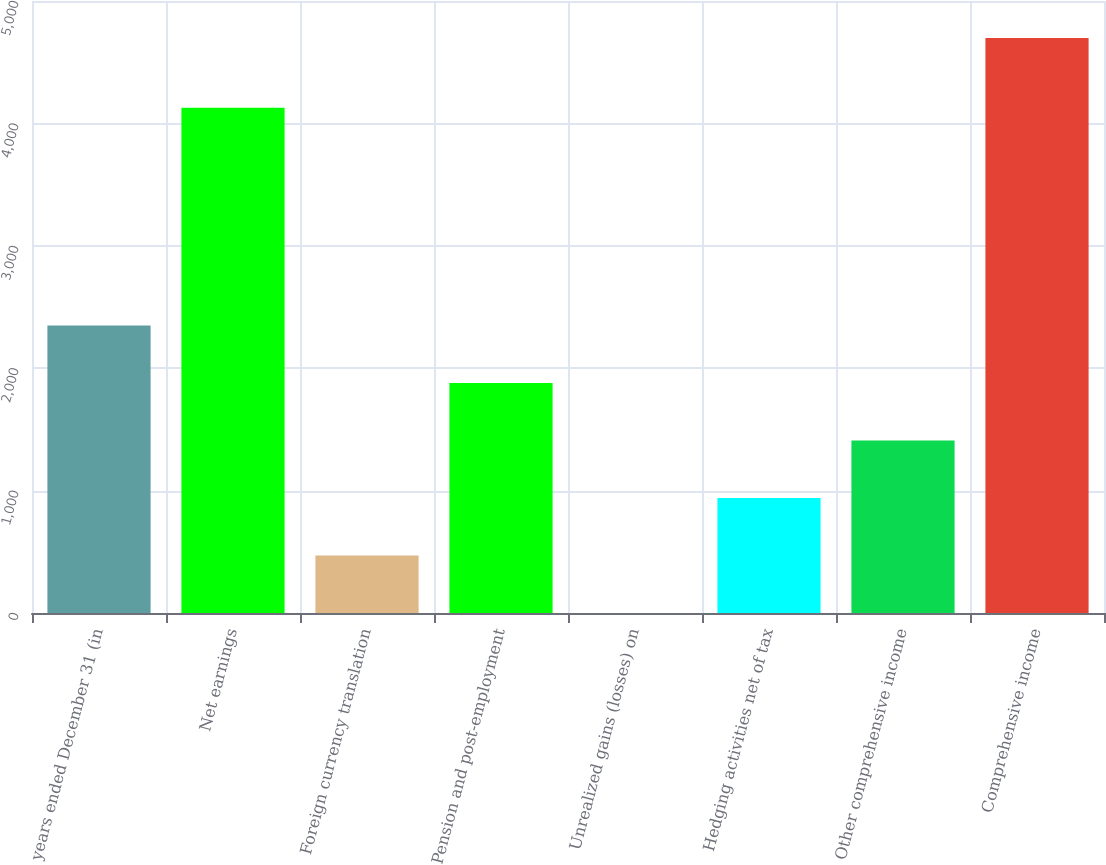<chart> <loc_0><loc_0><loc_500><loc_500><bar_chart><fcel>years ended December 31 (in<fcel>Net earnings<fcel>Foreign currency translation<fcel>Pension and post-employment<fcel>Unrealized gains (losses) on<fcel>Hedging activities net of tax<fcel>Other comprehensive income<fcel>Comprehensive income<nl><fcel>2349.5<fcel>4128<fcel>470.7<fcel>1879.8<fcel>1<fcel>940.4<fcel>1410.1<fcel>4698<nl></chart> 